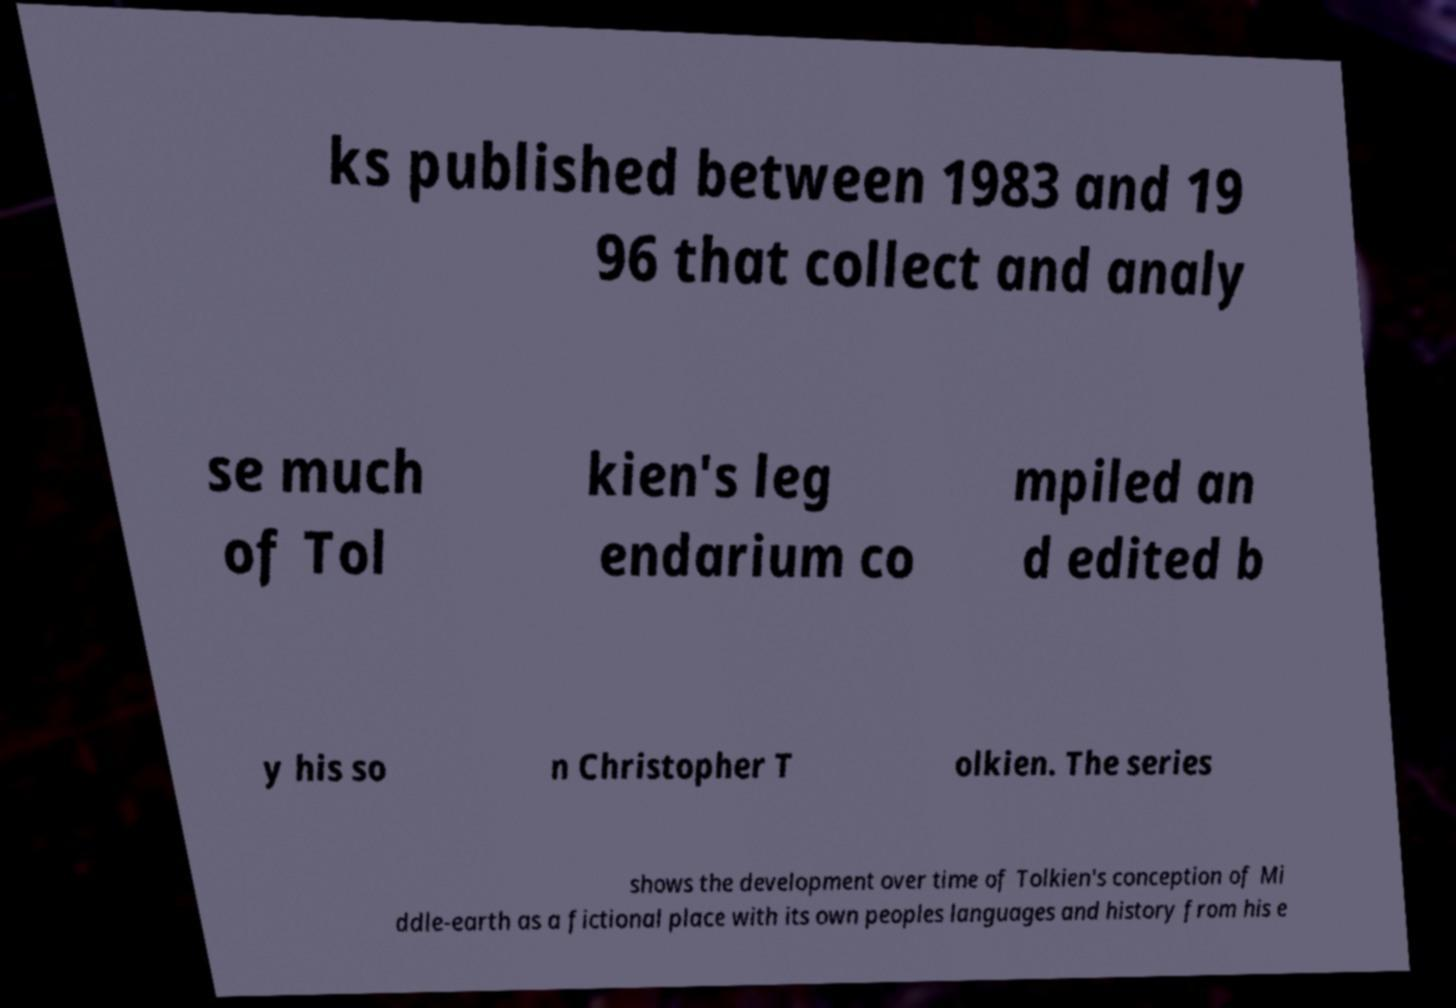I need the written content from this picture converted into text. Can you do that? ks published between 1983 and 19 96 that collect and analy se much of Tol kien's leg endarium co mpiled an d edited b y his so n Christopher T olkien. The series shows the development over time of Tolkien's conception of Mi ddle-earth as a fictional place with its own peoples languages and history from his e 